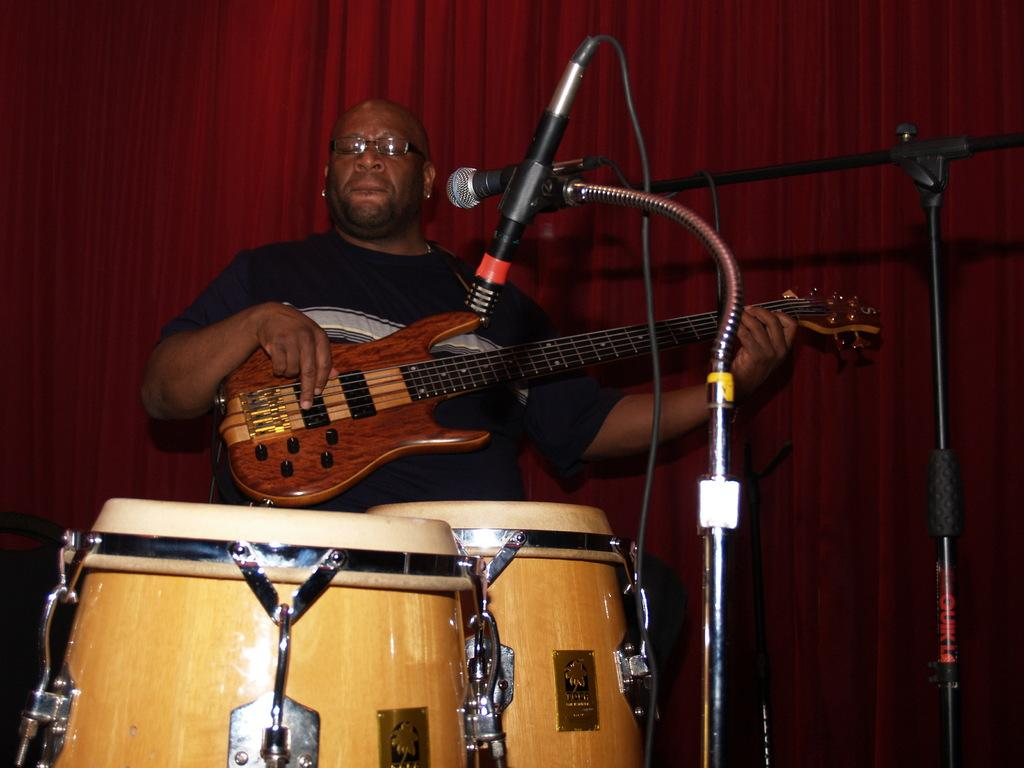What is the man in the image doing? The man is playing a guitar in the image. What accessories is the man wearing? The man is wearing spectacles in the image. What other musical instruments can be seen in the image? There are musical drums in the image. What equipment is present for amplifying sound? There is a microphone (mike) in the image. What can be seen in the background of the image? There is a curtain in the background of the image. How does the man wash his clothes in the image? There is no indication of clothes washing in the image; the man is playing a guitar. 